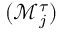Convert formula to latex. <formula><loc_0><loc_0><loc_500><loc_500>( \mathcal { M } _ { j } ^ { \tau } )</formula> 